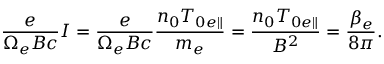Convert formula to latex. <formula><loc_0><loc_0><loc_500><loc_500>\frac { e } { \Omega _ { e } B c } I = \frac { e } { \Omega _ { e } B c } \frac { n _ { 0 } T _ { 0 e \| } } { m _ { e } } = \frac { n _ { 0 } T _ { 0 e \| } } { B ^ { 2 } } = \frac { \beta _ { e } } { 8 \pi } .</formula> 